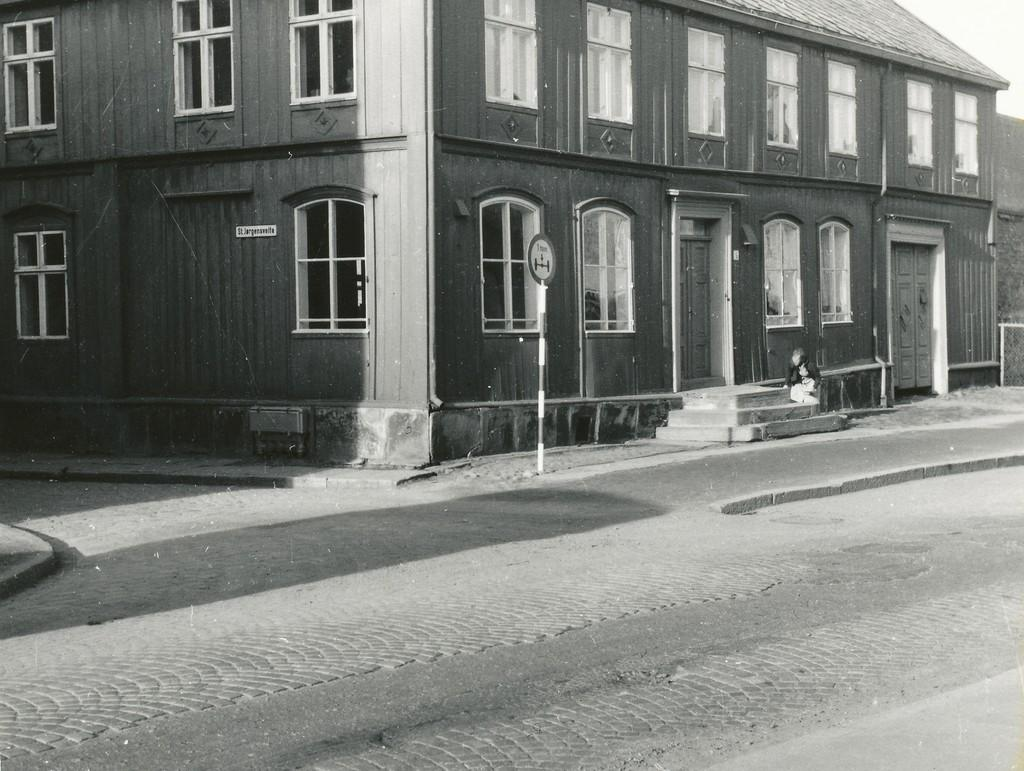What type of structure is in the picture? There is a building in the picture. What features can be seen on the building? The building has windows and doors. Are there any architectural elements visible in the picture? Yes, there are stairs in the picture. What else can be seen in the image besides the building? There is a road in the picture. What is the condition of the sky in the image? The sky is clear in the image. Can you tell me how many fans are visible in the image? There are no fans present in the image. Is there a crate being used as a makeshift table in the image? There is no crate present in the image. 